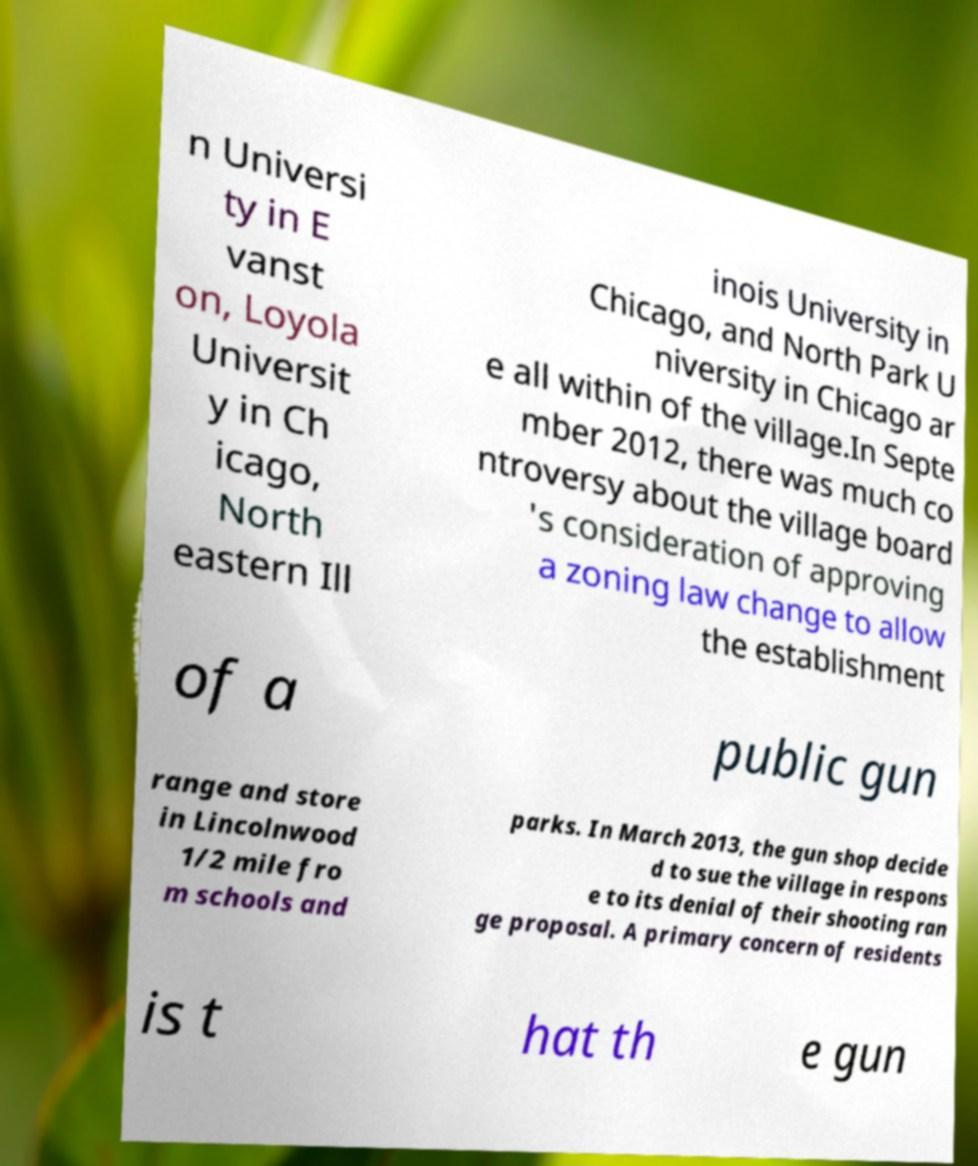What messages or text are displayed in this image? I need them in a readable, typed format. n Universi ty in E vanst on, Loyola Universit y in Ch icago, North eastern Ill inois University in Chicago, and North Park U niversity in Chicago ar e all within of the village.In Septe mber 2012, there was much co ntroversy about the village board 's consideration of approving a zoning law change to allow the establishment of a public gun range and store in Lincolnwood 1/2 mile fro m schools and parks. In March 2013, the gun shop decide d to sue the village in respons e to its denial of their shooting ran ge proposal. A primary concern of residents is t hat th e gun 